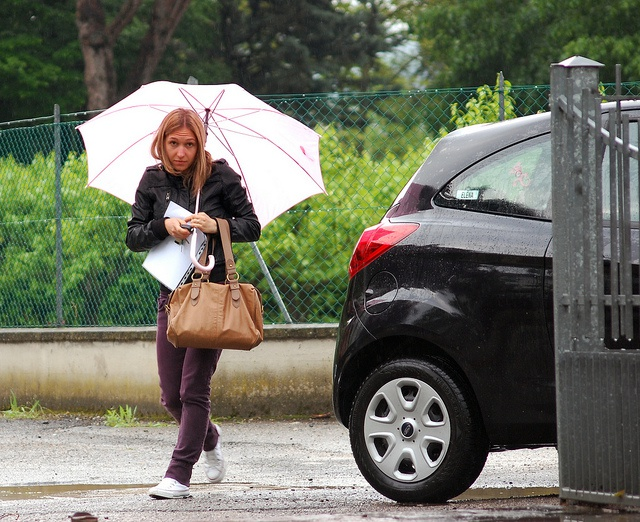Describe the objects in this image and their specific colors. I can see car in black, darkgray, gray, and lightgray tones, people in black, maroon, lightgray, and brown tones, umbrella in black, white, lightpink, pink, and brown tones, handbag in black, salmon, tan, and maroon tones, and cell phone in black, gray, darkgray, and maroon tones in this image. 